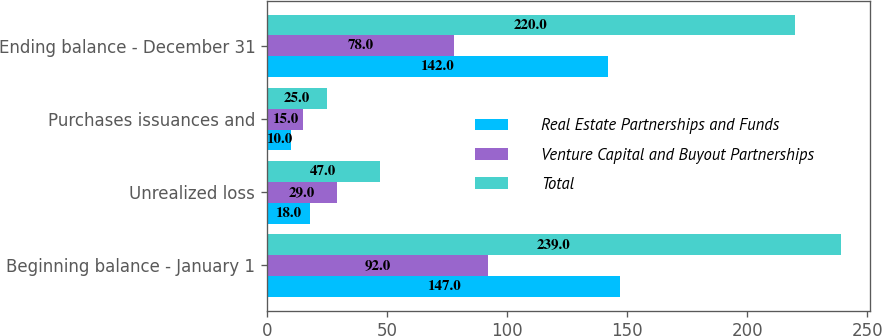<chart> <loc_0><loc_0><loc_500><loc_500><stacked_bar_chart><ecel><fcel>Beginning balance - January 1<fcel>Unrealized loss<fcel>Purchases issuances and<fcel>Ending balance - December 31<nl><fcel>Real Estate Partnerships and Funds<fcel>147<fcel>18<fcel>10<fcel>142<nl><fcel>Venture Capital and Buyout Partnerships<fcel>92<fcel>29<fcel>15<fcel>78<nl><fcel>Total<fcel>239<fcel>47<fcel>25<fcel>220<nl></chart> 